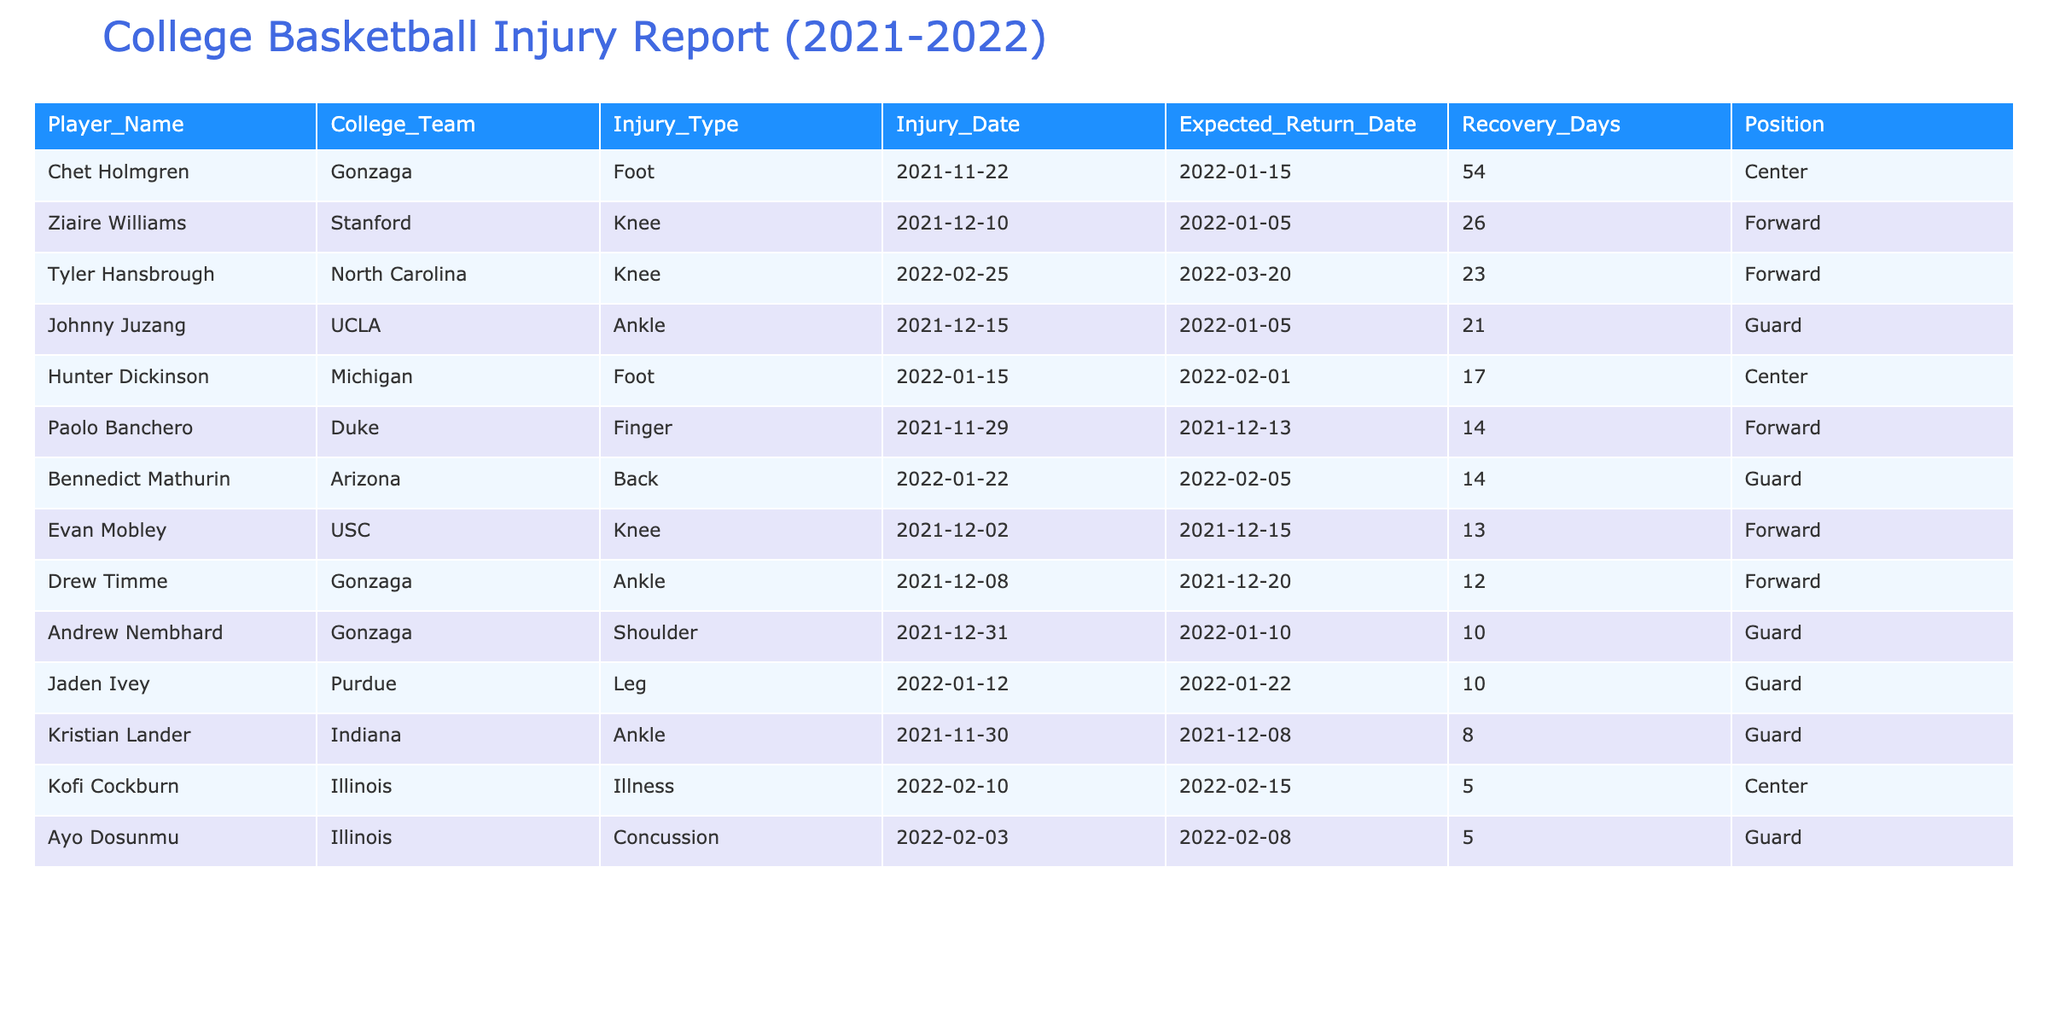What is the longest recovery time among the players listed? By looking at the 'Recovery_Days' column, the player with the longest recovery time is Chet Holmgren with 54 days.
Answer: 54 days Which player returned from injury the fastest? From the 'Recovery_Days' column, Drew Timme returned in just 12 days, which is the shortest recovery time listed.
Answer: 12 days How many players missed games due to ankle injuries? Filter through the 'Injury_Type' column for the term 'Ankle', which applies to Drew Timme, Johnny Juzang, and Kristian Lander, making a total of 3 players.
Answer: 3 players What is the average recovery time for players returning from knee injuries? Considering only the knee injuries (Tyler Hansbrough and Ziaire Williams), the recovery days are 23 and 26 respectively. The average is (23 + 26) / 2 = 24.5 days.
Answer: 24.5 days Did any player suffer multiple injuries during the season? Looking through the table, each player listed appears to have only a single injury case; therefore, the answer is no.
Answer: No Which college team had the highest number of players listed in the injury report? Analyzing the table, Gonzaga has three players: Chet Holmgren, Drew Timme, and Andrew Nembhard, making it the team with the highest number of injury cases.
Answer: Gonzaga How many players had recovery times shorter than 15 days? Filtering the recovery times indicates Drew Timme (12 days), Kofi Cockburn (5 days), Ayo Dosunmu (5 days), and Kristian Lander (8 days), totaling 4 players.
Answer: 4 players What is the total number of days lost due to injuries for the players listed? Summing all recovery days listed (54 + 12 + 5 + 14 + 21 + 10 + 26 + 10 + 5 + 23 + 8 + 17 + 13 + 14) equals  4 + 10 + 5 + 12 + 54 + 10 + 26 + 21 = 470 days lost.
Answer: 470 days 